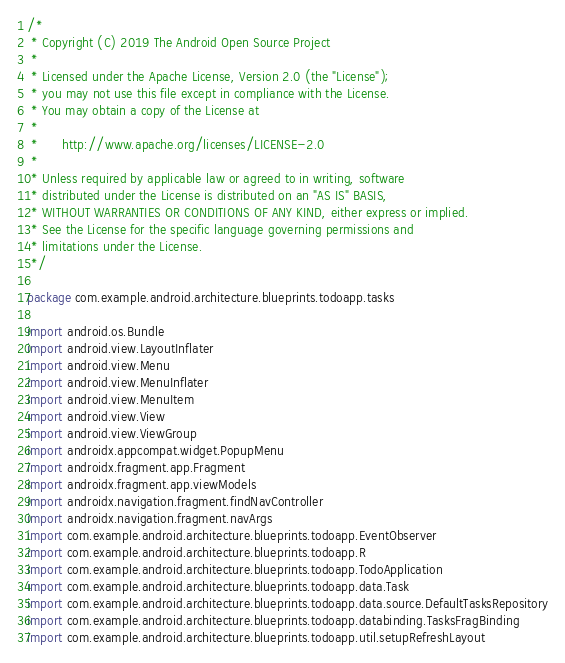Convert code to text. <code><loc_0><loc_0><loc_500><loc_500><_Kotlin_>/*
 * Copyright (C) 2019 The Android Open Source Project
 *
 * Licensed under the Apache License, Version 2.0 (the "License");
 * you may not use this file except in compliance with the License.
 * You may obtain a copy of the License at
 *
 *      http://www.apache.org/licenses/LICENSE-2.0
 *
 * Unless required by applicable law or agreed to in writing, software
 * distributed under the License is distributed on an "AS IS" BASIS,
 * WITHOUT WARRANTIES OR CONDITIONS OF ANY KIND, either express or implied.
 * See the License for the specific language governing permissions and
 * limitations under the License.
 */

package com.example.android.architecture.blueprints.todoapp.tasks

import android.os.Bundle
import android.view.LayoutInflater
import android.view.Menu
import android.view.MenuInflater
import android.view.MenuItem
import android.view.View
import android.view.ViewGroup
import androidx.appcompat.widget.PopupMenu
import androidx.fragment.app.Fragment
import androidx.fragment.app.viewModels
import androidx.navigation.fragment.findNavController
import androidx.navigation.fragment.navArgs
import com.example.android.architecture.blueprints.todoapp.EventObserver
import com.example.android.architecture.blueprints.todoapp.R
import com.example.android.architecture.blueprints.todoapp.TodoApplication
import com.example.android.architecture.blueprints.todoapp.data.Task
import com.example.android.architecture.blueprints.todoapp.data.source.DefaultTasksRepository
import com.example.android.architecture.blueprints.todoapp.databinding.TasksFragBinding
import com.example.android.architecture.blueprints.todoapp.util.setupRefreshLayout</code> 